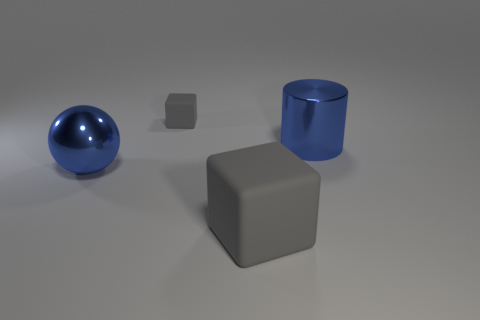Could you describe the atmosphere or mood of this image? The image has a calm, minimalistic atmosphere with a cool color palette. The smooth surfaces and simple geometry lend it a modern or abstract feel. It's organized in a way that might evoke contemplation or calmness. 